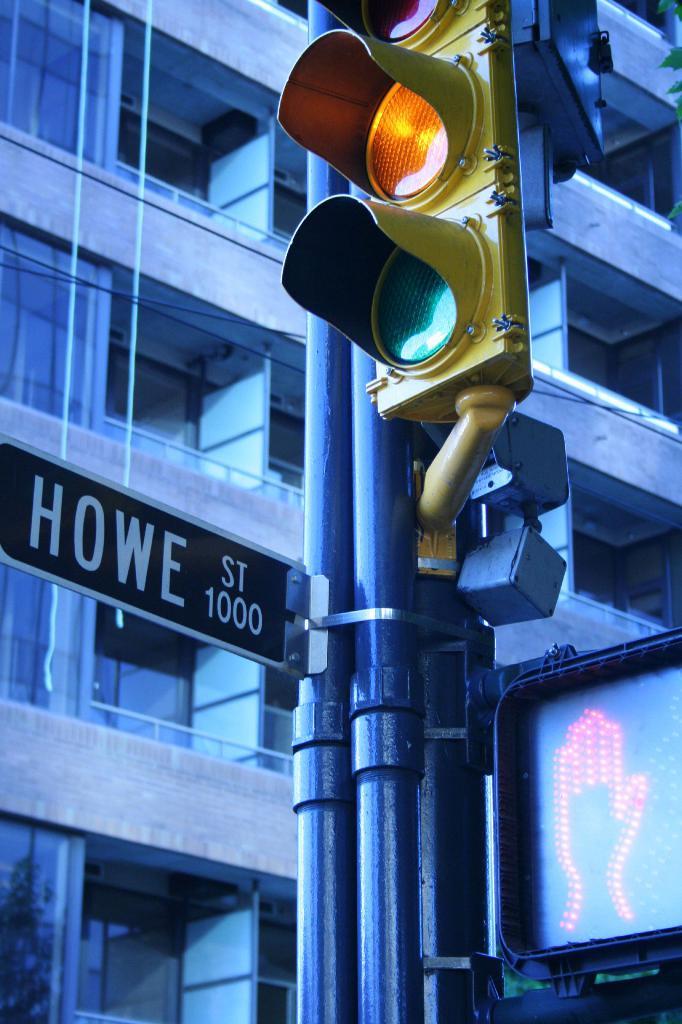What street is listed here?
Offer a very short reply. Howe st. What number is on the sign?
Keep it short and to the point. 1000. 